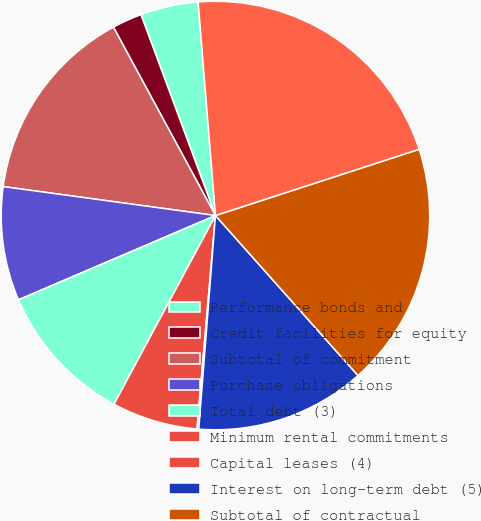Convert chart to OTSL. <chart><loc_0><loc_0><loc_500><loc_500><pie_chart><fcel>Performance bonds and<fcel>Credit facilities for equity<fcel>Subtotal of commitment<fcel>Purchase obligations<fcel>Total debt (3)<fcel>Minimum rental commitments<fcel>Capital leases (4)<fcel>Interest on long-term debt (5)<fcel>Subtotal of contractual<fcel>Total commitments and<nl><fcel>4.36%<fcel>2.25%<fcel>14.94%<fcel>8.59%<fcel>10.71%<fcel>6.48%<fcel>0.13%<fcel>12.82%<fcel>18.42%<fcel>21.28%<nl></chart> 